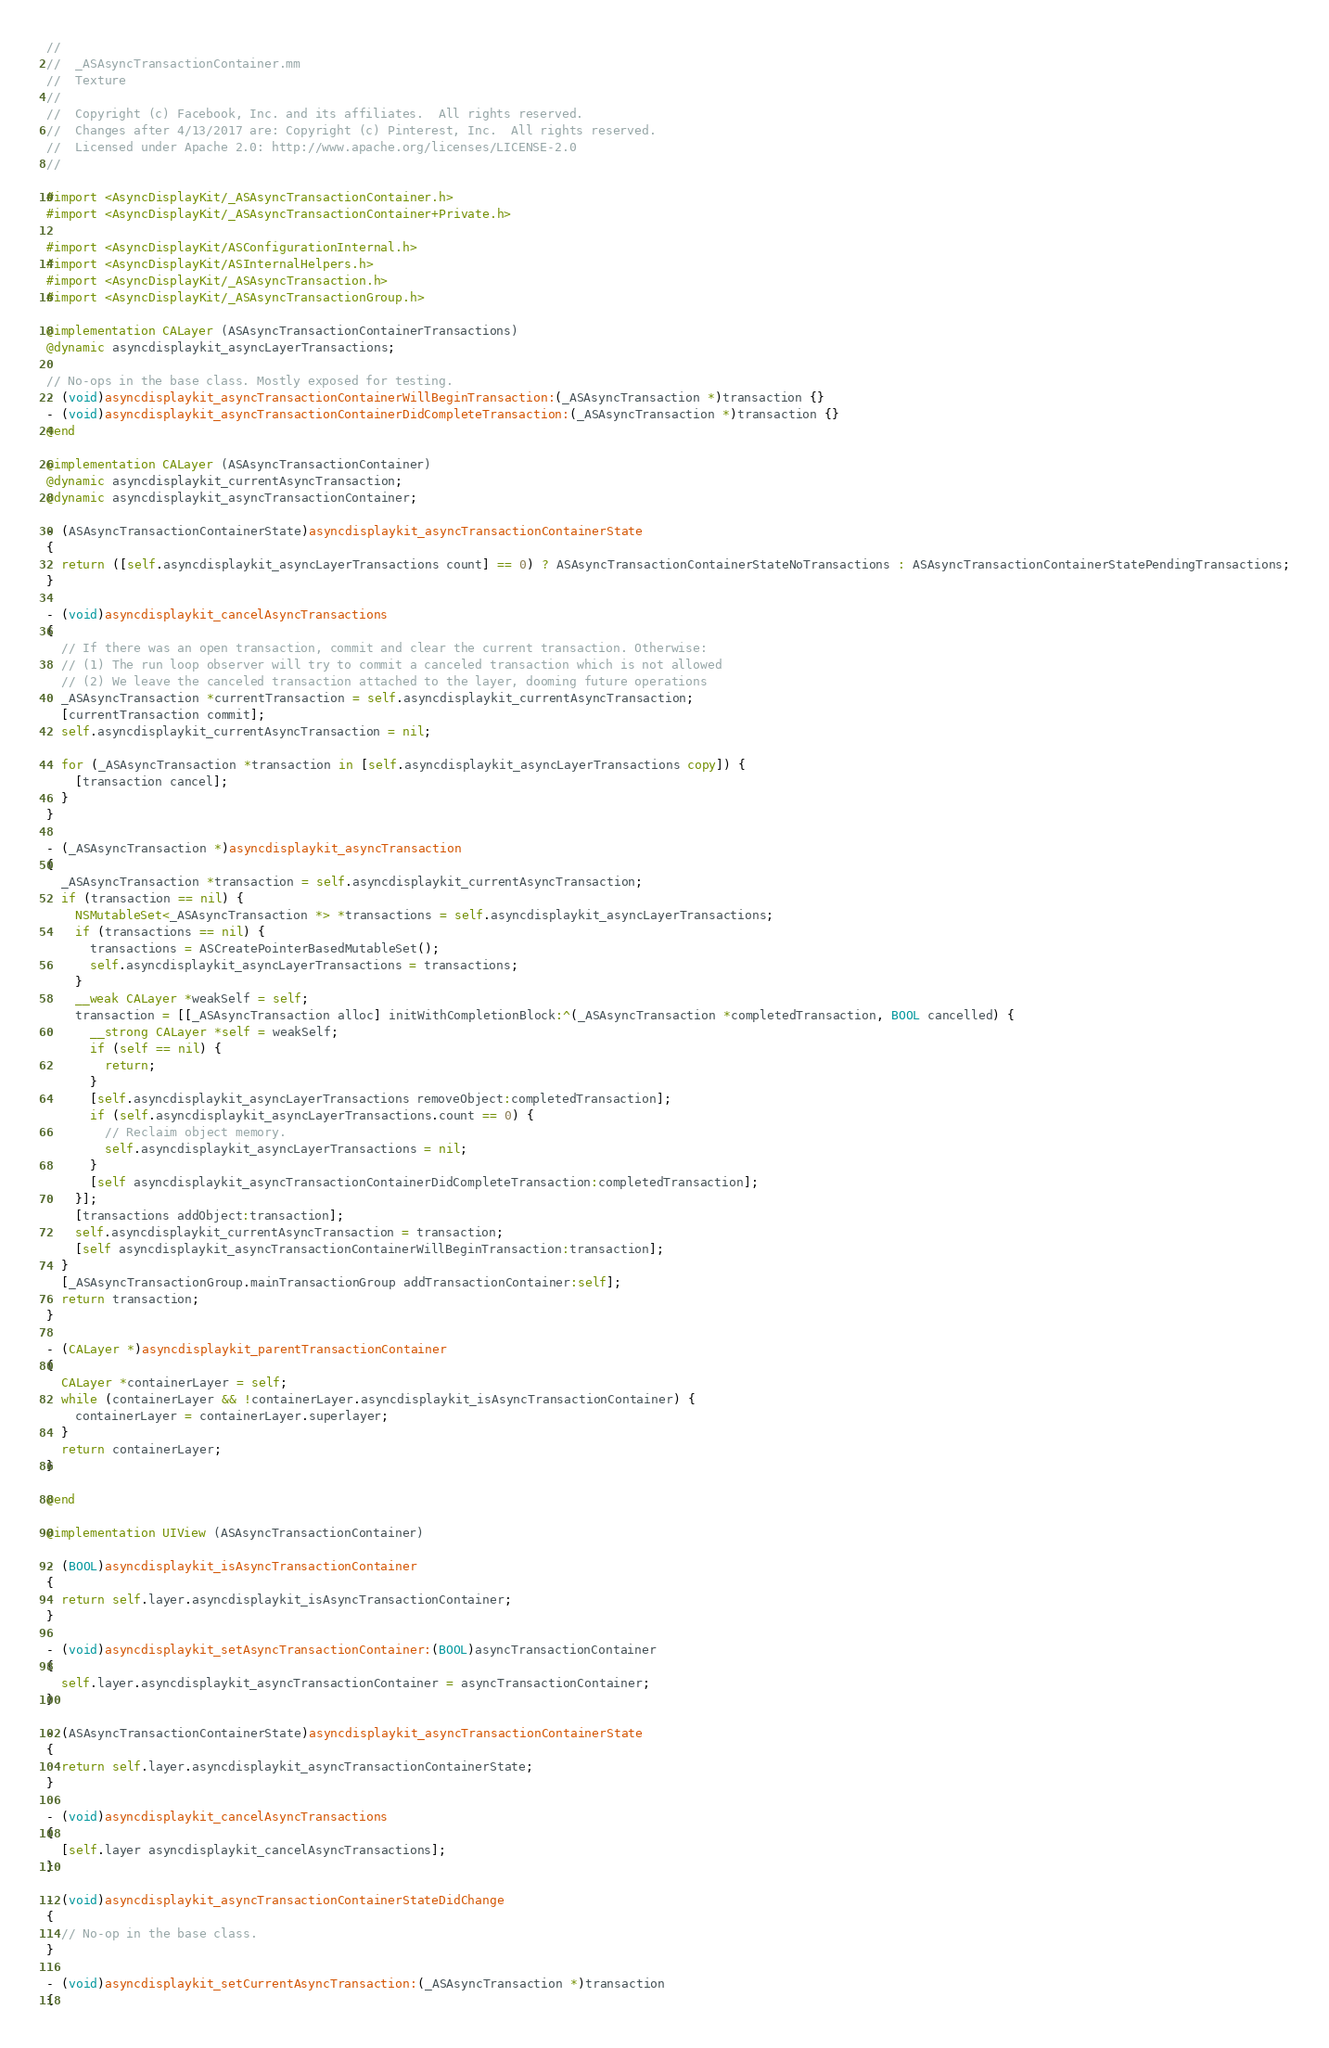Convert code to text. <code><loc_0><loc_0><loc_500><loc_500><_ObjectiveC_>//
//  _ASAsyncTransactionContainer.mm
//  Texture
//
//  Copyright (c) Facebook, Inc. and its affiliates.  All rights reserved.
//  Changes after 4/13/2017 are: Copyright (c) Pinterest, Inc.  All rights reserved.
//  Licensed under Apache 2.0: http://www.apache.org/licenses/LICENSE-2.0
//

#import <AsyncDisplayKit/_ASAsyncTransactionContainer.h>
#import <AsyncDisplayKit/_ASAsyncTransactionContainer+Private.h>

#import <AsyncDisplayKit/ASConfigurationInternal.h>
#import <AsyncDisplayKit/ASInternalHelpers.h>
#import <AsyncDisplayKit/_ASAsyncTransaction.h>
#import <AsyncDisplayKit/_ASAsyncTransactionGroup.h>

@implementation CALayer (ASAsyncTransactionContainerTransactions)
@dynamic asyncdisplaykit_asyncLayerTransactions;

// No-ops in the base class. Mostly exposed for testing.
- (void)asyncdisplaykit_asyncTransactionContainerWillBeginTransaction:(_ASAsyncTransaction *)transaction {}
- (void)asyncdisplaykit_asyncTransactionContainerDidCompleteTransaction:(_ASAsyncTransaction *)transaction {}
@end

@implementation CALayer (ASAsyncTransactionContainer)
@dynamic asyncdisplaykit_currentAsyncTransaction;
@dynamic asyncdisplaykit_asyncTransactionContainer;

- (ASAsyncTransactionContainerState)asyncdisplaykit_asyncTransactionContainerState
{
  return ([self.asyncdisplaykit_asyncLayerTransactions count] == 0) ? ASAsyncTransactionContainerStateNoTransactions : ASAsyncTransactionContainerStatePendingTransactions;
}

- (void)asyncdisplaykit_cancelAsyncTransactions
{
  // If there was an open transaction, commit and clear the current transaction. Otherwise:
  // (1) The run loop observer will try to commit a canceled transaction which is not allowed
  // (2) We leave the canceled transaction attached to the layer, dooming future operations
  _ASAsyncTransaction *currentTransaction = self.asyncdisplaykit_currentAsyncTransaction;
  [currentTransaction commit];
  self.asyncdisplaykit_currentAsyncTransaction = nil;

  for (_ASAsyncTransaction *transaction in [self.asyncdisplaykit_asyncLayerTransactions copy]) {
    [transaction cancel];
  }
}

- (_ASAsyncTransaction *)asyncdisplaykit_asyncTransaction
{
  _ASAsyncTransaction *transaction = self.asyncdisplaykit_currentAsyncTransaction;
  if (transaction == nil) {
    NSMutableSet<_ASAsyncTransaction *> *transactions = self.asyncdisplaykit_asyncLayerTransactions;
    if (transactions == nil) {
      transactions = ASCreatePointerBasedMutableSet();
      self.asyncdisplaykit_asyncLayerTransactions = transactions;
    }
    __weak CALayer *weakSelf = self;
    transaction = [[_ASAsyncTransaction alloc] initWithCompletionBlock:^(_ASAsyncTransaction *completedTransaction, BOOL cancelled) {
      __strong CALayer *self = weakSelf;
      if (self == nil) {
        return;
      }
      [self.asyncdisplaykit_asyncLayerTransactions removeObject:completedTransaction];
      if (self.asyncdisplaykit_asyncLayerTransactions.count == 0) {
        // Reclaim object memory.
        self.asyncdisplaykit_asyncLayerTransactions = nil;
      }
      [self asyncdisplaykit_asyncTransactionContainerDidCompleteTransaction:completedTransaction];
    }];
    [transactions addObject:transaction];
    self.asyncdisplaykit_currentAsyncTransaction = transaction;
    [self asyncdisplaykit_asyncTransactionContainerWillBeginTransaction:transaction];
  }
  [_ASAsyncTransactionGroup.mainTransactionGroup addTransactionContainer:self];
  return transaction;
}

- (CALayer *)asyncdisplaykit_parentTransactionContainer
{
  CALayer *containerLayer = self;
  while (containerLayer && !containerLayer.asyncdisplaykit_isAsyncTransactionContainer) {
    containerLayer = containerLayer.superlayer;
  }
  return containerLayer;
}

@end

@implementation UIView (ASAsyncTransactionContainer)

- (BOOL)asyncdisplaykit_isAsyncTransactionContainer
{
  return self.layer.asyncdisplaykit_isAsyncTransactionContainer;
}

- (void)asyncdisplaykit_setAsyncTransactionContainer:(BOOL)asyncTransactionContainer
{
  self.layer.asyncdisplaykit_asyncTransactionContainer = asyncTransactionContainer;
}

- (ASAsyncTransactionContainerState)asyncdisplaykit_asyncTransactionContainerState
{
  return self.layer.asyncdisplaykit_asyncTransactionContainerState;
}

- (void)asyncdisplaykit_cancelAsyncTransactions
{
  [self.layer asyncdisplaykit_cancelAsyncTransactions];
}

- (void)asyncdisplaykit_asyncTransactionContainerStateDidChange
{
  // No-op in the base class.
}

- (void)asyncdisplaykit_setCurrentAsyncTransaction:(_ASAsyncTransaction *)transaction
{</code> 